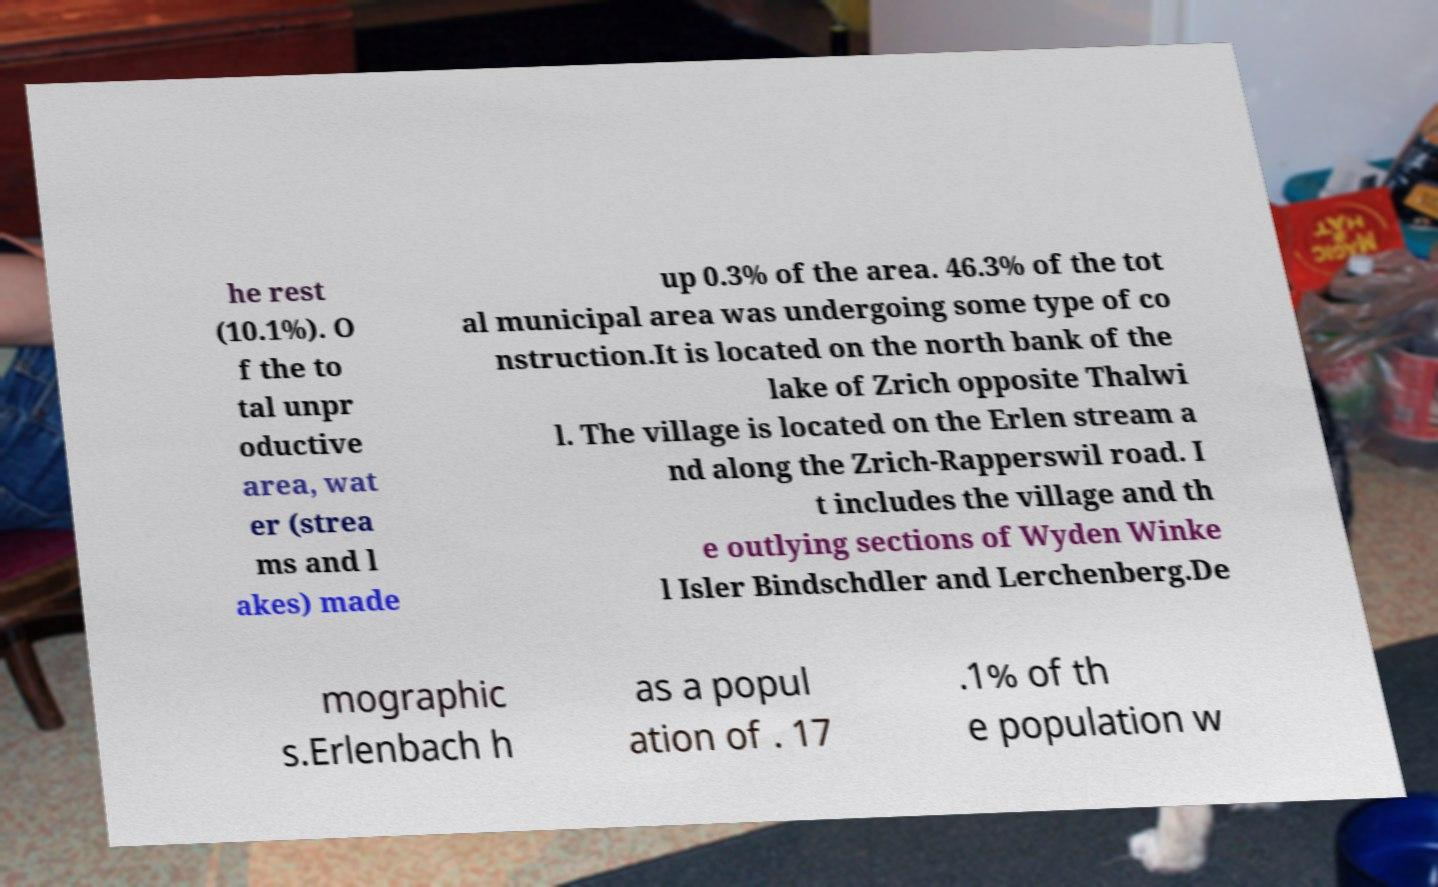Could you assist in decoding the text presented in this image and type it out clearly? he rest (10.1%). O f the to tal unpr oductive area, wat er (strea ms and l akes) made up 0.3% of the area. 46.3% of the tot al municipal area was undergoing some type of co nstruction.It is located on the north bank of the lake of Zrich opposite Thalwi l. The village is located on the Erlen stream a nd along the Zrich-Rapperswil road. I t includes the village and th e outlying sections of Wyden Winke l Isler Bindschdler and Lerchenberg.De mographic s.Erlenbach h as a popul ation of . 17 .1% of th e population w 